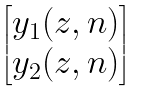<formula> <loc_0><loc_0><loc_500><loc_500>\begin{bmatrix} y _ { 1 } ( z , n ) \\ y _ { 2 } ( z , n ) \end{bmatrix}</formula> 